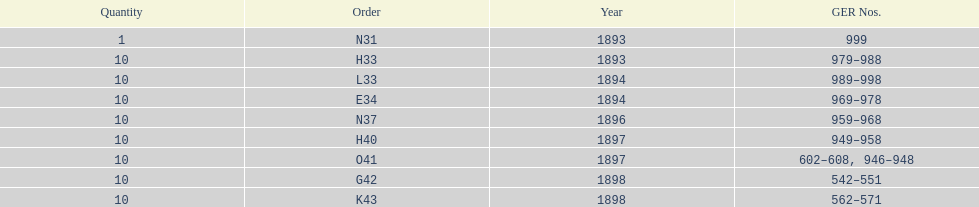Was the quantity higher in 1894 or 1893? 1894. 